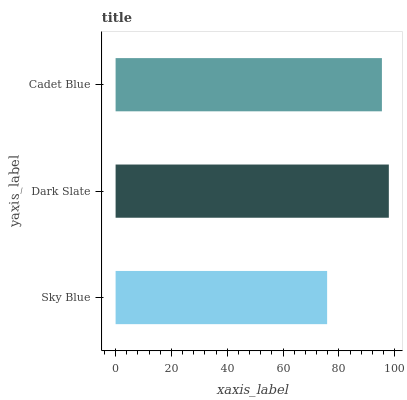Is Sky Blue the minimum?
Answer yes or no. Yes. Is Dark Slate the maximum?
Answer yes or no. Yes. Is Cadet Blue the minimum?
Answer yes or no. No. Is Cadet Blue the maximum?
Answer yes or no. No. Is Dark Slate greater than Cadet Blue?
Answer yes or no. Yes. Is Cadet Blue less than Dark Slate?
Answer yes or no. Yes. Is Cadet Blue greater than Dark Slate?
Answer yes or no. No. Is Dark Slate less than Cadet Blue?
Answer yes or no. No. Is Cadet Blue the high median?
Answer yes or no. Yes. Is Cadet Blue the low median?
Answer yes or no. Yes. Is Dark Slate the high median?
Answer yes or no. No. Is Sky Blue the low median?
Answer yes or no. No. 